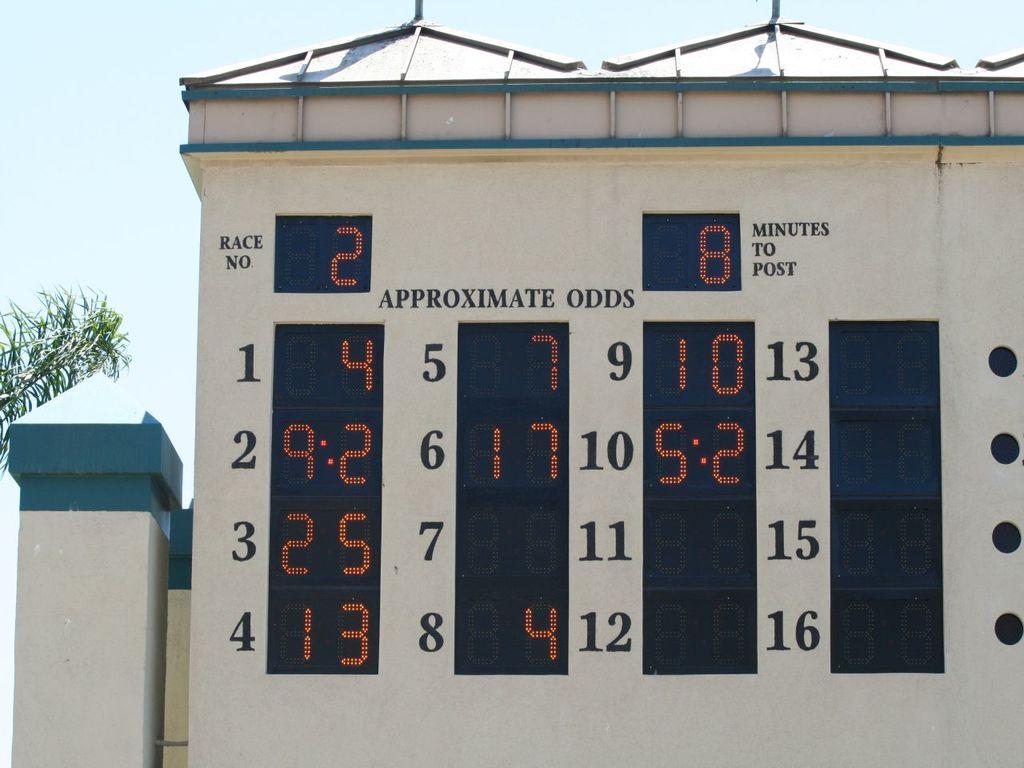What two numbers are to the right of "10" in the white space?
Your answer should be very brief. 13. 